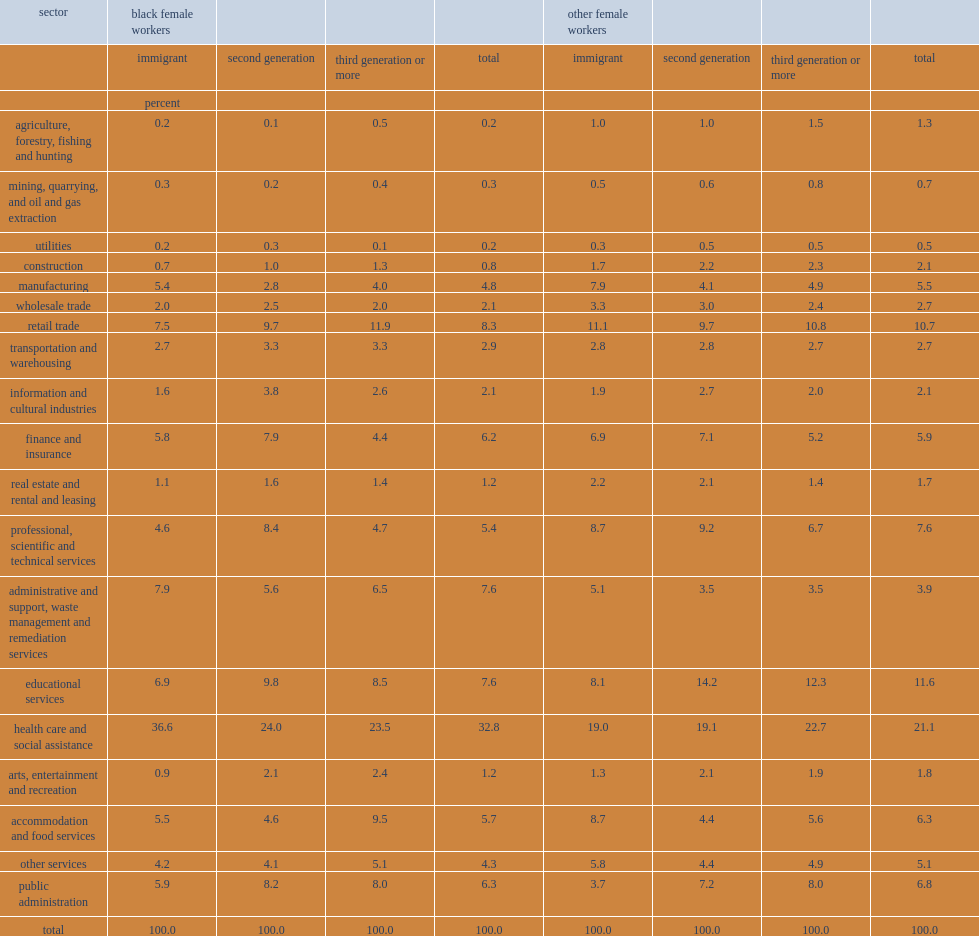Which sector has the most black female workers? Health care and social assistance. Which sector has the most black female workers? 11.7. Among immigrant women, how many percent of black immigrant women worked in the health care and social assistance sector was higher than other immigrant women? 17.6. 